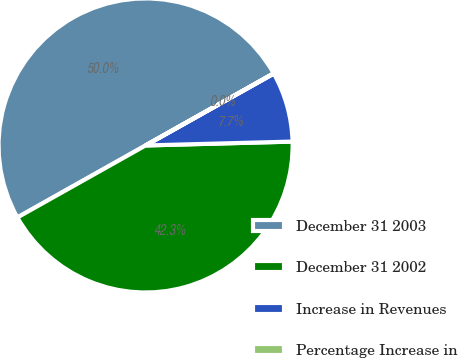Convert chart. <chart><loc_0><loc_0><loc_500><loc_500><pie_chart><fcel>December 31 2003<fcel>December 31 2002<fcel>Increase in Revenues<fcel>Percentage Increase in<nl><fcel>49.98%<fcel>42.27%<fcel>7.71%<fcel>0.03%<nl></chart> 